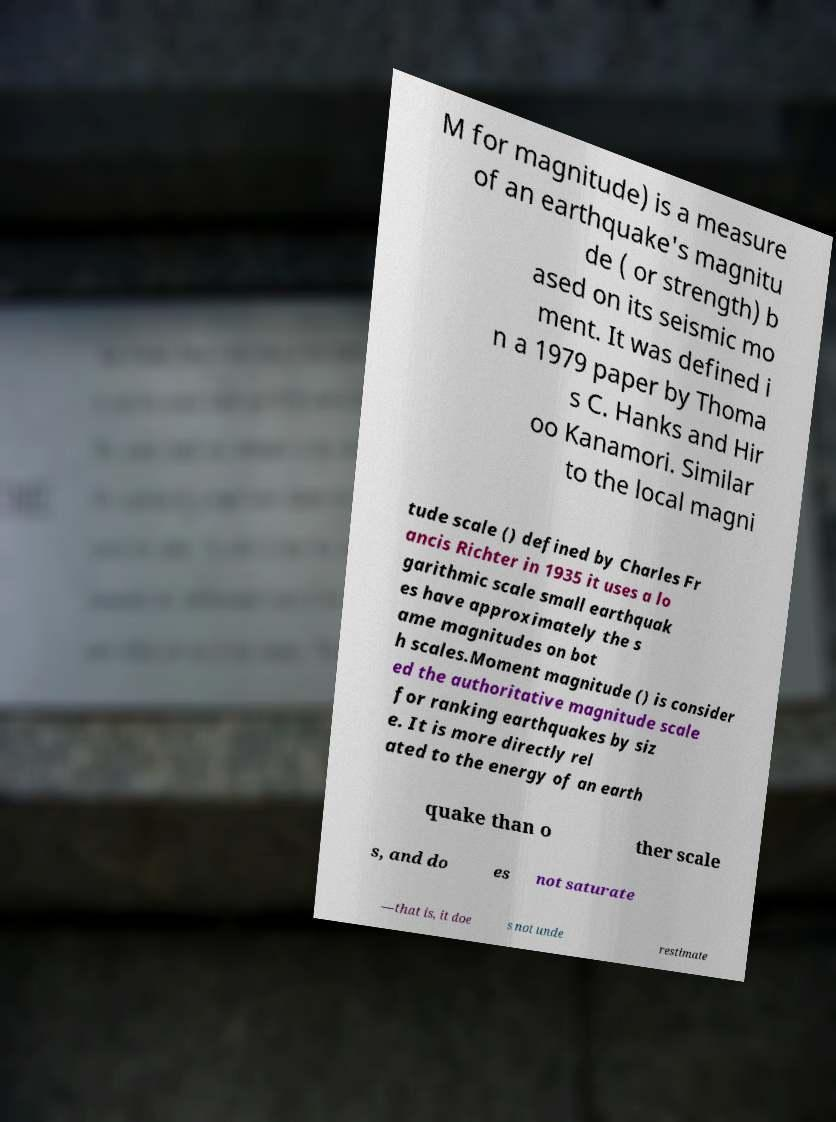Can you read and provide the text displayed in the image?This photo seems to have some interesting text. Can you extract and type it out for me? M for magnitude) is a measure of an earthquake's magnitu de ( or strength) b ased on its seismic mo ment. It was defined i n a 1979 paper by Thoma s C. Hanks and Hir oo Kanamori. Similar to the local magni tude scale () defined by Charles Fr ancis Richter in 1935 it uses a lo garithmic scale small earthquak es have approximately the s ame magnitudes on bot h scales.Moment magnitude () is consider ed the authoritative magnitude scale for ranking earthquakes by siz e. It is more directly rel ated to the energy of an earth quake than o ther scale s, and do es not saturate —that is, it doe s not unde restimate 